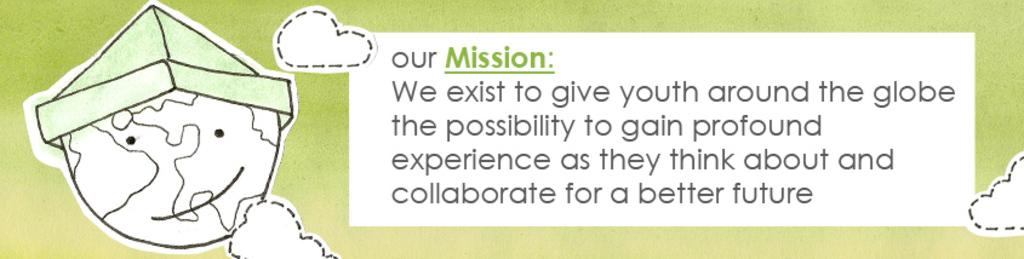What is the main subject in the center of the image? There is a poster in the center of the image. What message does the poster convey? The poster has the text "Our Mission" written on it. What is the name of the town mentioned in the image? There is no town mentioned in the image; the poster only has the text "Our Mission" written on it. How does the poster help people improve their hearing? The poster does not mention anything about hearing or improving it; it only has the text "Our Mission" on it. 